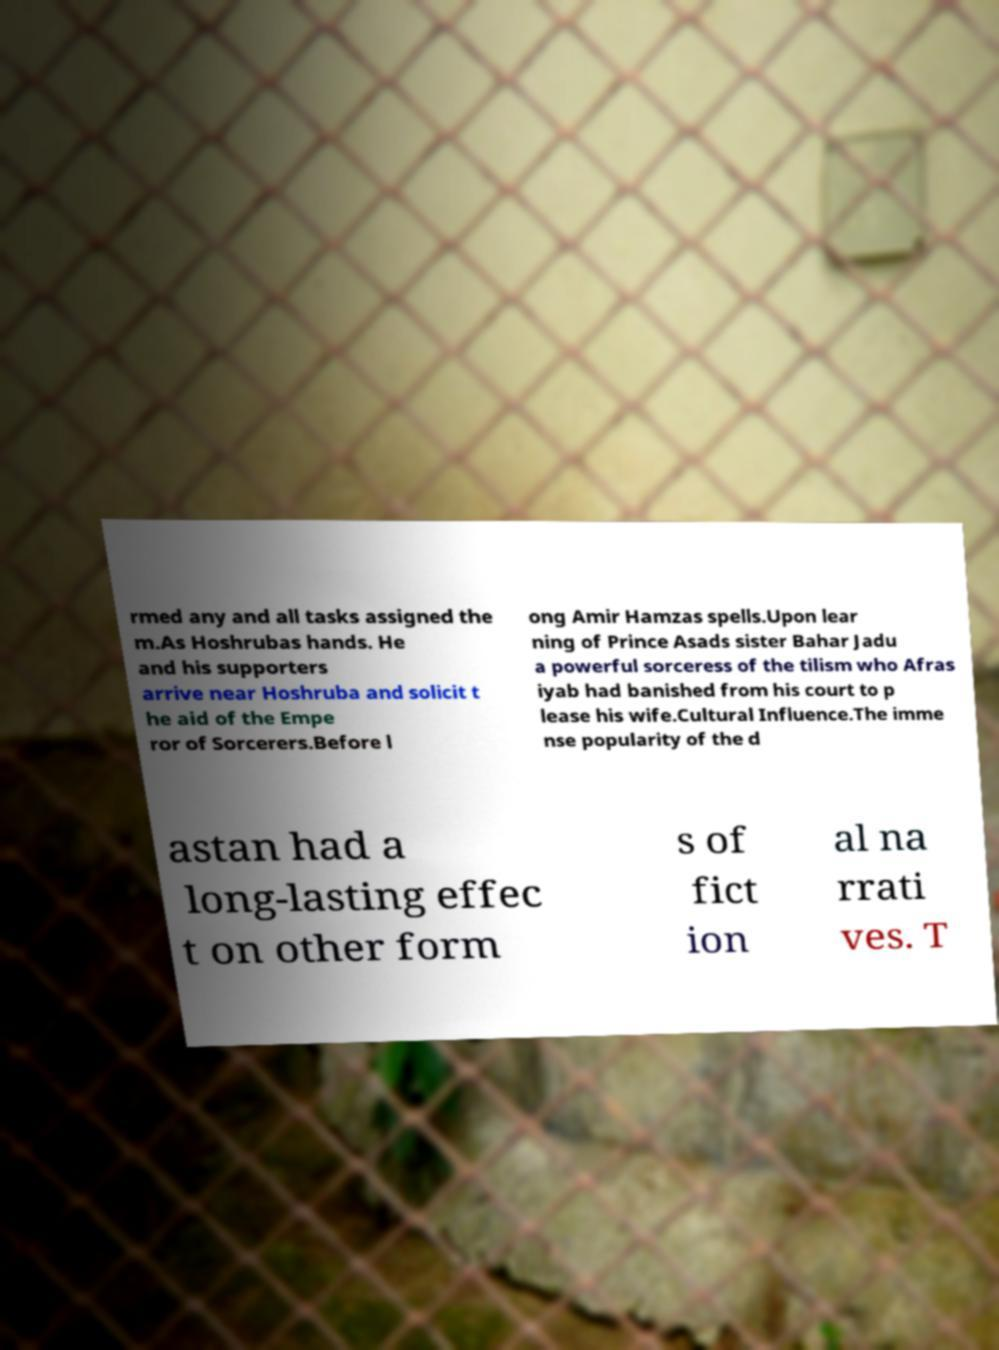For documentation purposes, I need the text within this image transcribed. Could you provide that? rmed any and all tasks assigned the m.As Hoshrubas hands. He and his supporters arrive near Hoshruba and solicit t he aid of the Empe ror of Sorcerers.Before l ong Amir Hamzas spells.Upon lear ning of Prince Asads sister Bahar Jadu a powerful sorceress of the tilism who Afras iyab had banished from his court to p lease his wife.Cultural Influence.The imme nse popularity of the d astan had a long-lasting effec t on other form s of fict ion al na rrati ves. T 